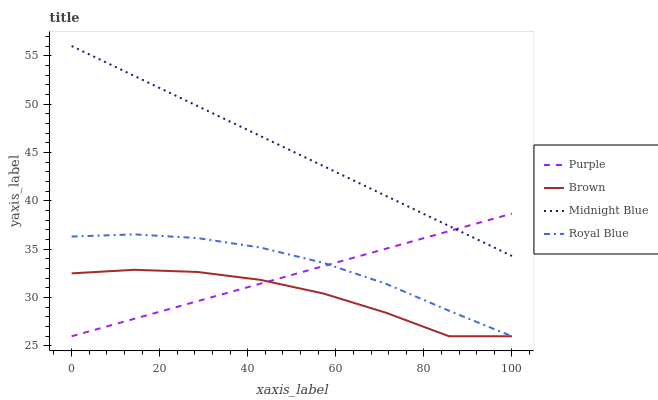Does Brown have the minimum area under the curve?
Answer yes or no. Yes. Does Midnight Blue have the maximum area under the curve?
Answer yes or no. Yes. Does Midnight Blue have the minimum area under the curve?
Answer yes or no. No. Does Brown have the maximum area under the curve?
Answer yes or no. No. Is Purple the smoothest?
Answer yes or no. Yes. Is Brown the roughest?
Answer yes or no. Yes. Is Midnight Blue the smoothest?
Answer yes or no. No. Is Midnight Blue the roughest?
Answer yes or no. No. Does Midnight Blue have the lowest value?
Answer yes or no. No. Does Midnight Blue have the highest value?
Answer yes or no. Yes. Does Brown have the highest value?
Answer yes or no. No. Is Brown less than Midnight Blue?
Answer yes or no. Yes. Is Midnight Blue greater than Royal Blue?
Answer yes or no. Yes. Does Purple intersect Midnight Blue?
Answer yes or no. Yes. Is Purple less than Midnight Blue?
Answer yes or no. No. Is Purple greater than Midnight Blue?
Answer yes or no. No. Does Brown intersect Midnight Blue?
Answer yes or no. No. 